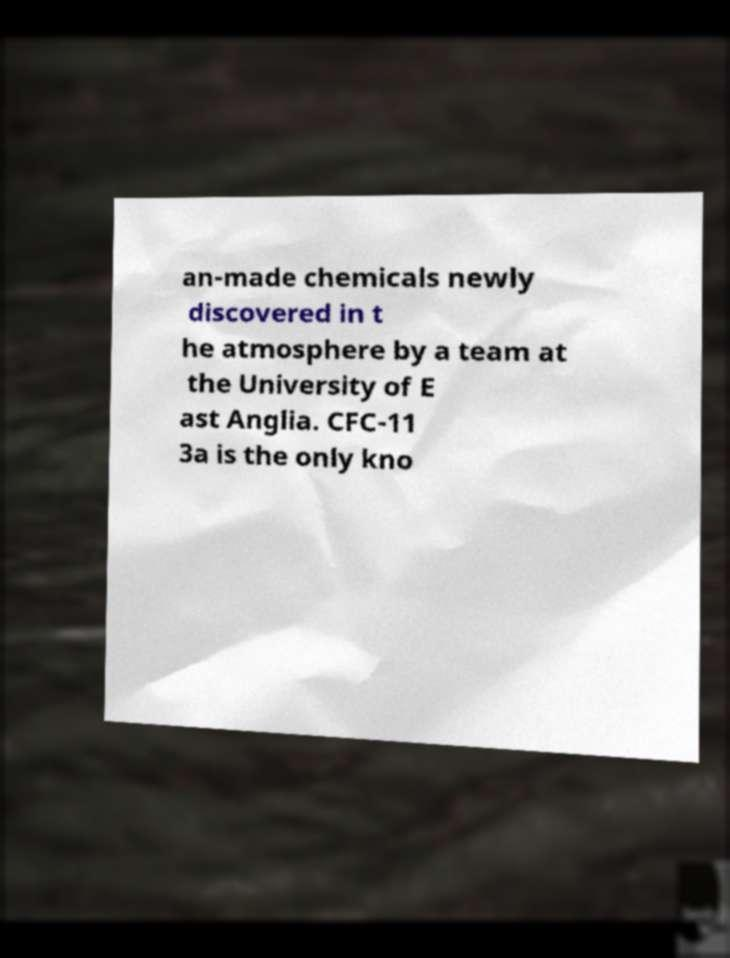Can you read and provide the text displayed in the image?This photo seems to have some interesting text. Can you extract and type it out for me? an-made chemicals newly discovered in t he atmosphere by a team at the University of E ast Anglia. CFC-11 3a is the only kno 